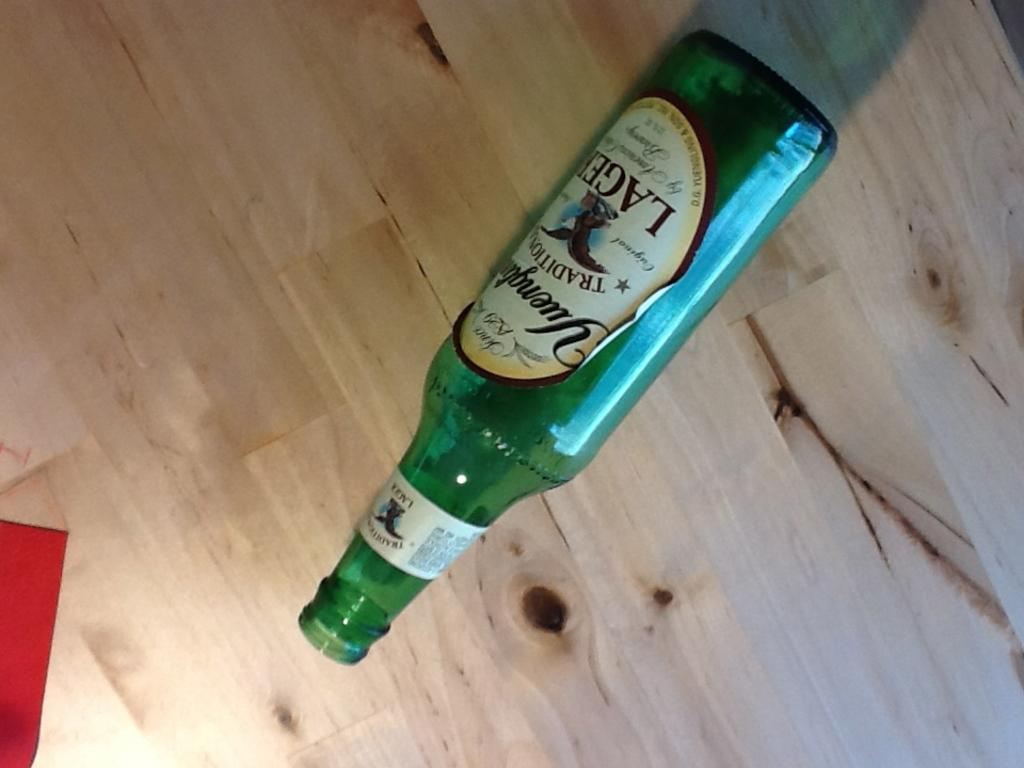<image>
Describe the image concisely. An empty bottle of Yuengling lager lying on its side. 